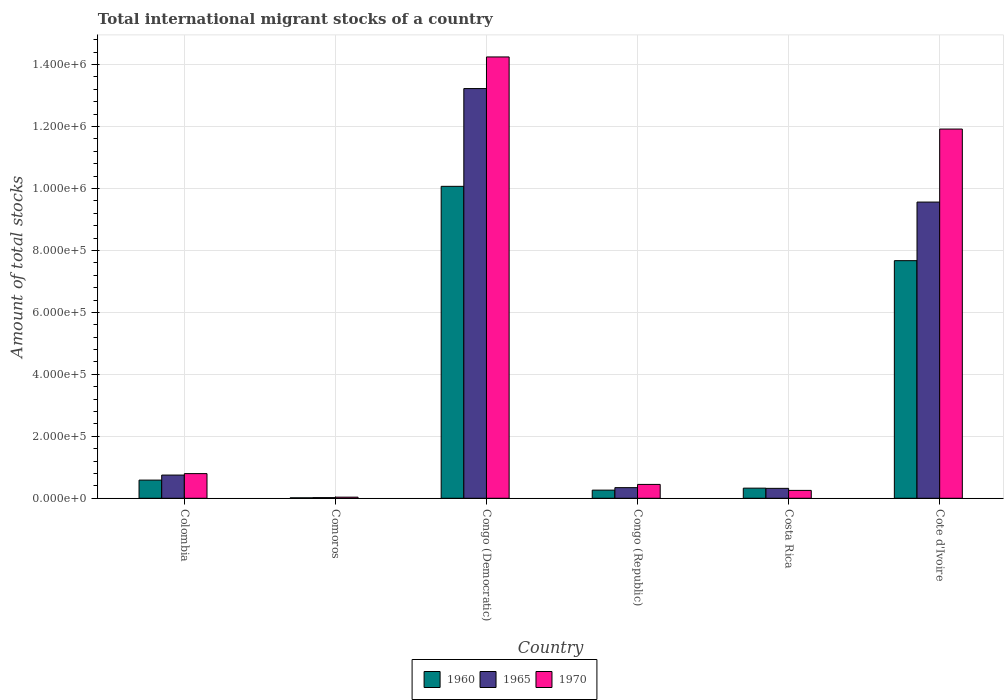How many groups of bars are there?
Your answer should be compact. 6. Are the number of bars on each tick of the X-axis equal?
Provide a short and direct response. Yes. What is the amount of total stocks in in 1965 in Comoros?
Give a very brief answer. 2138. Across all countries, what is the maximum amount of total stocks in in 1965?
Ensure brevity in your answer.  1.32e+06. Across all countries, what is the minimum amount of total stocks in in 1965?
Give a very brief answer. 2138. In which country was the amount of total stocks in in 1970 maximum?
Offer a very short reply. Congo (Democratic). In which country was the amount of total stocks in in 1965 minimum?
Offer a terse response. Comoros. What is the total amount of total stocks in in 1965 in the graph?
Make the answer very short. 2.42e+06. What is the difference between the amount of total stocks in in 1970 in Colombia and that in Congo (Democratic)?
Provide a succinct answer. -1.34e+06. What is the difference between the amount of total stocks in in 1965 in Congo (Democratic) and the amount of total stocks in in 1970 in Costa Rica?
Offer a terse response. 1.30e+06. What is the average amount of total stocks in in 1965 per country?
Your answer should be very brief. 4.04e+05. What is the difference between the amount of total stocks in of/in 1960 and amount of total stocks in of/in 1965 in Comoros?
Give a very brief answer. -631. What is the ratio of the amount of total stocks in in 1960 in Congo (Democratic) to that in Cote d'Ivoire?
Your answer should be compact. 1.31. Is the amount of total stocks in in 1960 in Colombia less than that in Congo (Democratic)?
Offer a terse response. Yes. What is the difference between the highest and the second highest amount of total stocks in in 1970?
Offer a very short reply. -2.33e+05. What is the difference between the highest and the lowest amount of total stocks in in 1960?
Ensure brevity in your answer.  1.01e+06. Is the sum of the amount of total stocks in in 1960 in Congo (Democratic) and Congo (Republic) greater than the maximum amount of total stocks in in 1965 across all countries?
Your response must be concise. No. What does the 1st bar from the left in Comoros represents?
Your answer should be compact. 1960. Is it the case that in every country, the sum of the amount of total stocks in in 1970 and amount of total stocks in in 1965 is greater than the amount of total stocks in in 1960?
Ensure brevity in your answer.  Yes. How many bars are there?
Give a very brief answer. 18. How many countries are there in the graph?
Make the answer very short. 6. What is the difference between two consecutive major ticks on the Y-axis?
Ensure brevity in your answer.  2.00e+05. Are the values on the major ticks of Y-axis written in scientific E-notation?
Give a very brief answer. Yes. Where does the legend appear in the graph?
Your answer should be very brief. Bottom center. What is the title of the graph?
Offer a terse response. Total international migrant stocks of a country. Does "1991" appear as one of the legend labels in the graph?
Your answer should be compact. No. What is the label or title of the Y-axis?
Your response must be concise. Amount of total stocks. What is the Amount of total stocks in 1960 in Colombia?
Give a very brief answer. 5.87e+04. What is the Amount of total stocks of 1965 in Colombia?
Your response must be concise. 7.49e+04. What is the Amount of total stocks of 1970 in Colombia?
Provide a succinct answer. 7.96e+04. What is the Amount of total stocks in 1960 in Comoros?
Offer a terse response. 1507. What is the Amount of total stocks in 1965 in Comoros?
Your response must be concise. 2138. What is the Amount of total stocks in 1970 in Comoros?
Provide a succinct answer. 3614. What is the Amount of total stocks of 1960 in Congo (Democratic)?
Provide a succinct answer. 1.01e+06. What is the Amount of total stocks in 1965 in Congo (Democratic)?
Keep it short and to the point. 1.32e+06. What is the Amount of total stocks in 1970 in Congo (Democratic)?
Offer a terse response. 1.42e+06. What is the Amount of total stocks of 1960 in Congo (Republic)?
Make the answer very short. 2.63e+04. What is the Amount of total stocks of 1965 in Congo (Republic)?
Your response must be concise. 3.43e+04. What is the Amount of total stocks of 1970 in Congo (Republic)?
Your answer should be compact. 4.48e+04. What is the Amount of total stocks in 1960 in Costa Rica?
Give a very brief answer. 3.27e+04. What is the Amount of total stocks of 1965 in Costa Rica?
Your response must be concise. 3.21e+04. What is the Amount of total stocks in 1970 in Costa Rica?
Your response must be concise. 2.54e+04. What is the Amount of total stocks of 1960 in Cote d'Ivoire?
Offer a terse response. 7.67e+05. What is the Amount of total stocks in 1965 in Cote d'Ivoire?
Ensure brevity in your answer.  9.56e+05. What is the Amount of total stocks in 1970 in Cote d'Ivoire?
Keep it short and to the point. 1.19e+06. Across all countries, what is the maximum Amount of total stocks of 1960?
Make the answer very short. 1.01e+06. Across all countries, what is the maximum Amount of total stocks in 1965?
Your answer should be compact. 1.32e+06. Across all countries, what is the maximum Amount of total stocks in 1970?
Your response must be concise. 1.42e+06. Across all countries, what is the minimum Amount of total stocks of 1960?
Your response must be concise. 1507. Across all countries, what is the minimum Amount of total stocks in 1965?
Give a very brief answer. 2138. Across all countries, what is the minimum Amount of total stocks of 1970?
Your answer should be very brief. 3614. What is the total Amount of total stocks in 1960 in the graph?
Provide a succinct answer. 1.89e+06. What is the total Amount of total stocks in 1965 in the graph?
Give a very brief answer. 2.42e+06. What is the total Amount of total stocks of 1970 in the graph?
Your answer should be compact. 2.77e+06. What is the difference between the Amount of total stocks of 1960 in Colombia and that in Comoros?
Provide a short and direct response. 5.72e+04. What is the difference between the Amount of total stocks of 1965 in Colombia and that in Comoros?
Provide a short and direct response. 7.28e+04. What is the difference between the Amount of total stocks of 1970 in Colombia and that in Comoros?
Offer a terse response. 7.60e+04. What is the difference between the Amount of total stocks in 1960 in Colombia and that in Congo (Democratic)?
Offer a terse response. -9.48e+05. What is the difference between the Amount of total stocks of 1965 in Colombia and that in Congo (Democratic)?
Give a very brief answer. -1.25e+06. What is the difference between the Amount of total stocks of 1970 in Colombia and that in Congo (Democratic)?
Provide a succinct answer. -1.34e+06. What is the difference between the Amount of total stocks of 1960 in Colombia and that in Congo (Republic)?
Your answer should be compact. 3.24e+04. What is the difference between the Amount of total stocks in 1965 in Colombia and that in Congo (Republic)?
Give a very brief answer. 4.06e+04. What is the difference between the Amount of total stocks of 1970 in Colombia and that in Congo (Republic)?
Offer a very short reply. 3.48e+04. What is the difference between the Amount of total stocks in 1960 in Colombia and that in Costa Rica?
Give a very brief answer. 2.60e+04. What is the difference between the Amount of total stocks of 1965 in Colombia and that in Costa Rica?
Your answer should be very brief. 4.28e+04. What is the difference between the Amount of total stocks of 1970 in Colombia and that in Costa Rica?
Offer a terse response. 5.42e+04. What is the difference between the Amount of total stocks of 1960 in Colombia and that in Cote d'Ivoire?
Your answer should be very brief. -7.08e+05. What is the difference between the Amount of total stocks in 1965 in Colombia and that in Cote d'Ivoire?
Offer a very short reply. -8.81e+05. What is the difference between the Amount of total stocks of 1970 in Colombia and that in Cote d'Ivoire?
Your answer should be very brief. -1.11e+06. What is the difference between the Amount of total stocks in 1960 in Comoros and that in Congo (Democratic)?
Your response must be concise. -1.01e+06. What is the difference between the Amount of total stocks in 1965 in Comoros and that in Congo (Democratic)?
Your response must be concise. -1.32e+06. What is the difference between the Amount of total stocks in 1970 in Comoros and that in Congo (Democratic)?
Ensure brevity in your answer.  -1.42e+06. What is the difference between the Amount of total stocks in 1960 in Comoros and that in Congo (Republic)?
Provide a succinct answer. -2.48e+04. What is the difference between the Amount of total stocks of 1965 in Comoros and that in Congo (Republic)?
Your answer should be compact. -3.22e+04. What is the difference between the Amount of total stocks in 1970 in Comoros and that in Congo (Republic)?
Your answer should be compact. -4.12e+04. What is the difference between the Amount of total stocks of 1960 in Comoros and that in Costa Rica?
Give a very brief answer. -3.12e+04. What is the difference between the Amount of total stocks in 1965 in Comoros and that in Costa Rica?
Your answer should be compact. -2.99e+04. What is the difference between the Amount of total stocks in 1970 in Comoros and that in Costa Rica?
Offer a very short reply. -2.18e+04. What is the difference between the Amount of total stocks of 1960 in Comoros and that in Cote d'Ivoire?
Your response must be concise. -7.66e+05. What is the difference between the Amount of total stocks of 1965 in Comoros and that in Cote d'Ivoire?
Provide a short and direct response. -9.54e+05. What is the difference between the Amount of total stocks of 1970 in Comoros and that in Cote d'Ivoire?
Your response must be concise. -1.19e+06. What is the difference between the Amount of total stocks of 1960 in Congo (Democratic) and that in Congo (Republic)?
Make the answer very short. 9.81e+05. What is the difference between the Amount of total stocks in 1965 in Congo (Democratic) and that in Congo (Republic)?
Your answer should be very brief. 1.29e+06. What is the difference between the Amount of total stocks in 1970 in Congo (Democratic) and that in Congo (Republic)?
Make the answer very short. 1.38e+06. What is the difference between the Amount of total stocks in 1960 in Congo (Democratic) and that in Costa Rica?
Your answer should be compact. 9.74e+05. What is the difference between the Amount of total stocks in 1965 in Congo (Democratic) and that in Costa Rica?
Make the answer very short. 1.29e+06. What is the difference between the Amount of total stocks in 1970 in Congo (Democratic) and that in Costa Rica?
Your response must be concise. 1.40e+06. What is the difference between the Amount of total stocks of 1960 in Congo (Democratic) and that in Cote d'Ivoire?
Keep it short and to the point. 2.40e+05. What is the difference between the Amount of total stocks in 1965 in Congo (Democratic) and that in Cote d'Ivoire?
Offer a terse response. 3.66e+05. What is the difference between the Amount of total stocks in 1970 in Congo (Democratic) and that in Cote d'Ivoire?
Give a very brief answer. 2.33e+05. What is the difference between the Amount of total stocks in 1960 in Congo (Republic) and that in Costa Rica?
Your answer should be compact. -6378. What is the difference between the Amount of total stocks of 1965 in Congo (Republic) and that in Costa Rica?
Make the answer very short. 2251. What is the difference between the Amount of total stocks of 1970 in Congo (Republic) and that in Costa Rica?
Provide a short and direct response. 1.93e+04. What is the difference between the Amount of total stocks in 1960 in Congo (Republic) and that in Cote d'Ivoire?
Provide a succinct answer. -7.41e+05. What is the difference between the Amount of total stocks in 1965 in Congo (Republic) and that in Cote d'Ivoire?
Offer a very short reply. -9.22e+05. What is the difference between the Amount of total stocks in 1970 in Congo (Republic) and that in Cote d'Ivoire?
Ensure brevity in your answer.  -1.15e+06. What is the difference between the Amount of total stocks of 1960 in Costa Rica and that in Cote d'Ivoire?
Ensure brevity in your answer.  -7.34e+05. What is the difference between the Amount of total stocks in 1965 in Costa Rica and that in Cote d'Ivoire?
Your answer should be very brief. -9.24e+05. What is the difference between the Amount of total stocks of 1970 in Costa Rica and that in Cote d'Ivoire?
Keep it short and to the point. -1.17e+06. What is the difference between the Amount of total stocks of 1960 in Colombia and the Amount of total stocks of 1965 in Comoros?
Provide a short and direct response. 5.65e+04. What is the difference between the Amount of total stocks of 1960 in Colombia and the Amount of total stocks of 1970 in Comoros?
Offer a very short reply. 5.51e+04. What is the difference between the Amount of total stocks in 1965 in Colombia and the Amount of total stocks in 1970 in Comoros?
Offer a very short reply. 7.13e+04. What is the difference between the Amount of total stocks in 1960 in Colombia and the Amount of total stocks in 1965 in Congo (Democratic)?
Your answer should be very brief. -1.26e+06. What is the difference between the Amount of total stocks in 1960 in Colombia and the Amount of total stocks in 1970 in Congo (Democratic)?
Your answer should be very brief. -1.37e+06. What is the difference between the Amount of total stocks of 1965 in Colombia and the Amount of total stocks of 1970 in Congo (Democratic)?
Your answer should be compact. -1.35e+06. What is the difference between the Amount of total stocks of 1960 in Colombia and the Amount of total stocks of 1965 in Congo (Republic)?
Your answer should be compact. 2.44e+04. What is the difference between the Amount of total stocks in 1960 in Colombia and the Amount of total stocks in 1970 in Congo (Republic)?
Your answer should be very brief. 1.39e+04. What is the difference between the Amount of total stocks in 1965 in Colombia and the Amount of total stocks in 1970 in Congo (Republic)?
Your answer should be very brief. 3.01e+04. What is the difference between the Amount of total stocks in 1960 in Colombia and the Amount of total stocks in 1965 in Costa Rica?
Give a very brief answer. 2.66e+04. What is the difference between the Amount of total stocks in 1960 in Colombia and the Amount of total stocks in 1970 in Costa Rica?
Your answer should be very brief. 3.32e+04. What is the difference between the Amount of total stocks of 1965 in Colombia and the Amount of total stocks of 1970 in Costa Rica?
Give a very brief answer. 4.95e+04. What is the difference between the Amount of total stocks in 1960 in Colombia and the Amount of total stocks in 1965 in Cote d'Ivoire?
Offer a very short reply. -8.97e+05. What is the difference between the Amount of total stocks in 1960 in Colombia and the Amount of total stocks in 1970 in Cote d'Ivoire?
Your answer should be very brief. -1.13e+06. What is the difference between the Amount of total stocks in 1965 in Colombia and the Amount of total stocks in 1970 in Cote d'Ivoire?
Make the answer very short. -1.12e+06. What is the difference between the Amount of total stocks of 1960 in Comoros and the Amount of total stocks of 1965 in Congo (Democratic)?
Your response must be concise. -1.32e+06. What is the difference between the Amount of total stocks in 1960 in Comoros and the Amount of total stocks in 1970 in Congo (Democratic)?
Your answer should be very brief. -1.42e+06. What is the difference between the Amount of total stocks in 1965 in Comoros and the Amount of total stocks in 1970 in Congo (Democratic)?
Give a very brief answer. -1.42e+06. What is the difference between the Amount of total stocks in 1960 in Comoros and the Amount of total stocks in 1965 in Congo (Republic)?
Make the answer very short. -3.28e+04. What is the difference between the Amount of total stocks in 1960 in Comoros and the Amount of total stocks in 1970 in Congo (Republic)?
Keep it short and to the point. -4.33e+04. What is the difference between the Amount of total stocks of 1965 in Comoros and the Amount of total stocks of 1970 in Congo (Republic)?
Your response must be concise. -4.26e+04. What is the difference between the Amount of total stocks of 1960 in Comoros and the Amount of total stocks of 1965 in Costa Rica?
Your answer should be very brief. -3.06e+04. What is the difference between the Amount of total stocks of 1960 in Comoros and the Amount of total stocks of 1970 in Costa Rica?
Your answer should be very brief. -2.39e+04. What is the difference between the Amount of total stocks in 1965 in Comoros and the Amount of total stocks in 1970 in Costa Rica?
Provide a short and direct response. -2.33e+04. What is the difference between the Amount of total stocks of 1960 in Comoros and the Amount of total stocks of 1965 in Cote d'Ivoire?
Make the answer very short. -9.55e+05. What is the difference between the Amount of total stocks of 1960 in Comoros and the Amount of total stocks of 1970 in Cote d'Ivoire?
Make the answer very short. -1.19e+06. What is the difference between the Amount of total stocks in 1965 in Comoros and the Amount of total stocks in 1970 in Cote d'Ivoire?
Keep it short and to the point. -1.19e+06. What is the difference between the Amount of total stocks of 1960 in Congo (Democratic) and the Amount of total stocks of 1965 in Congo (Republic)?
Your answer should be compact. 9.73e+05. What is the difference between the Amount of total stocks of 1960 in Congo (Democratic) and the Amount of total stocks of 1970 in Congo (Republic)?
Your answer should be compact. 9.62e+05. What is the difference between the Amount of total stocks in 1965 in Congo (Democratic) and the Amount of total stocks in 1970 in Congo (Republic)?
Your answer should be very brief. 1.28e+06. What is the difference between the Amount of total stocks of 1960 in Congo (Democratic) and the Amount of total stocks of 1965 in Costa Rica?
Provide a short and direct response. 9.75e+05. What is the difference between the Amount of total stocks in 1960 in Congo (Democratic) and the Amount of total stocks in 1970 in Costa Rica?
Provide a short and direct response. 9.81e+05. What is the difference between the Amount of total stocks in 1965 in Congo (Democratic) and the Amount of total stocks in 1970 in Costa Rica?
Your response must be concise. 1.30e+06. What is the difference between the Amount of total stocks of 1960 in Congo (Democratic) and the Amount of total stocks of 1965 in Cote d'Ivoire?
Provide a succinct answer. 5.08e+04. What is the difference between the Amount of total stocks of 1960 in Congo (Democratic) and the Amount of total stocks of 1970 in Cote d'Ivoire?
Offer a very short reply. -1.85e+05. What is the difference between the Amount of total stocks of 1965 in Congo (Democratic) and the Amount of total stocks of 1970 in Cote d'Ivoire?
Give a very brief answer. 1.31e+05. What is the difference between the Amount of total stocks in 1960 in Congo (Republic) and the Amount of total stocks in 1965 in Costa Rica?
Keep it short and to the point. -5758. What is the difference between the Amount of total stocks in 1960 in Congo (Republic) and the Amount of total stocks in 1970 in Costa Rica?
Your response must be concise. 883. What is the difference between the Amount of total stocks in 1965 in Congo (Republic) and the Amount of total stocks in 1970 in Costa Rica?
Your answer should be compact. 8892. What is the difference between the Amount of total stocks in 1960 in Congo (Republic) and the Amount of total stocks in 1965 in Cote d'Ivoire?
Offer a terse response. -9.30e+05. What is the difference between the Amount of total stocks in 1960 in Congo (Republic) and the Amount of total stocks in 1970 in Cote d'Ivoire?
Give a very brief answer. -1.17e+06. What is the difference between the Amount of total stocks of 1965 in Congo (Republic) and the Amount of total stocks of 1970 in Cote d'Ivoire?
Offer a very short reply. -1.16e+06. What is the difference between the Amount of total stocks in 1960 in Costa Rica and the Amount of total stocks in 1965 in Cote d'Ivoire?
Ensure brevity in your answer.  -9.23e+05. What is the difference between the Amount of total stocks of 1960 in Costa Rica and the Amount of total stocks of 1970 in Cote d'Ivoire?
Keep it short and to the point. -1.16e+06. What is the difference between the Amount of total stocks of 1965 in Costa Rica and the Amount of total stocks of 1970 in Cote d'Ivoire?
Give a very brief answer. -1.16e+06. What is the average Amount of total stocks in 1960 per country?
Your answer should be very brief. 3.16e+05. What is the average Amount of total stocks of 1965 per country?
Offer a very short reply. 4.04e+05. What is the average Amount of total stocks of 1970 per country?
Provide a succinct answer. 4.62e+05. What is the difference between the Amount of total stocks of 1960 and Amount of total stocks of 1965 in Colombia?
Offer a terse response. -1.62e+04. What is the difference between the Amount of total stocks in 1960 and Amount of total stocks in 1970 in Colombia?
Your response must be concise. -2.09e+04. What is the difference between the Amount of total stocks of 1965 and Amount of total stocks of 1970 in Colombia?
Ensure brevity in your answer.  -4673. What is the difference between the Amount of total stocks in 1960 and Amount of total stocks in 1965 in Comoros?
Your response must be concise. -631. What is the difference between the Amount of total stocks in 1960 and Amount of total stocks in 1970 in Comoros?
Offer a terse response. -2107. What is the difference between the Amount of total stocks of 1965 and Amount of total stocks of 1970 in Comoros?
Provide a short and direct response. -1476. What is the difference between the Amount of total stocks of 1960 and Amount of total stocks of 1965 in Congo (Democratic)?
Your answer should be compact. -3.16e+05. What is the difference between the Amount of total stocks of 1960 and Amount of total stocks of 1970 in Congo (Democratic)?
Ensure brevity in your answer.  -4.18e+05. What is the difference between the Amount of total stocks of 1965 and Amount of total stocks of 1970 in Congo (Democratic)?
Make the answer very short. -1.02e+05. What is the difference between the Amount of total stocks of 1960 and Amount of total stocks of 1965 in Congo (Republic)?
Make the answer very short. -8009. What is the difference between the Amount of total stocks of 1960 and Amount of total stocks of 1970 in Congo (Republic)?
Provide a short and direct response. -1.85e+04. What is the difference between the Amount of total stocks in 1965 and Amount of total stocks in 1970 in Congo (Republic)?
Make the answer very short. -1.04e+04. What is the difference between the Amount of total stocks in 1960 and Amount of total stocks in 1965 in Costa Rica?
Make the answer very short. 620. What is the difference between the Amount of total stocks in 1960 and Amount of total stocks in 1970 in Costa Rica?
Provide a succinct answer. 7261. What is the difference between the Amount of total stocks in 1965 and Amount of total stocks in 1970 in Costa Rica?
Give a very brief answer. 6641. What is the difference between the Amount of total stocks in 1960 and Amount of total stocks in 1965 in Cote d'Ivoire?
Provide a succinct answer. -1.89e+05. What is the difference between the Amount of total stocks in 1960 and Amount of total stocks in 1970 in Cote d'Ivoire?
Give a very brief answer. -4.25e+05. What is the difference between the Amount of total stocks of 1965 and Amount of total stocks of 1970 in Cote d'Ivoire?
Your answer should be very brief. -2.36e+05. What is the ratio of the Amount of total stocks of 1960 in Colombia to that in Comoros?
Make the answer very short. 38.94. What is the ratio of the Amount of total stocks of 1965 in Colombia to that in Comoros?
Your answer should be very brief. 35.04. What is the ratio of the Amount of total stocks in 1970 in Colombia to that in Comoros?
Keep it short and to the point. 22.02. What is the ratio of the Amount of total stocks of 1960 in Colombia to that in Congo (Democratic)?
Give a very brief answer. 0.06. What is the ratio of the Amount of total stocks in 1965 in Colombia to that in Congo (Democratic)?
Offer a terse response. 0.06. What is the ratio of the Amount of total stocks in 1970 in Colombia to that in Congo (Democratic)?
Your response must be concise. 0.06. What is the ratio of the Amount of total stocks of 1960 in Colombia to that in Congo (Republic)?
Make the answer very short. 2.23. What is the ratio of the Amount of total stocks in 1965 in Colombia to that in Congo (Republic)?
Give a very brief answer. 2.18. What is the ratio of the Amount of total stocks in 1970 in Colombia to that in Congo (Republic)?
Your answer should be compact. 1.78. What is the ratio of the Amount of total stocks of 1960 in Colombia to that in Costa Rica?
Your answer should be very brief. 1.79. What is the ratio of the Amount of total stocks in 1965 in Colombia to that in Costa Rica?
Your response must be concise. 2.34. What is the ratio of the Amount of total stocks in 1970 in Colombia to that in Costa Rica?
Offer a very short reply. 3.13. What is the ratio of the Amount of total stocks in 1960 in Colombia to that in Cote d'Ivoire?
Keep it short and to the point. 0.08. What is the ratio of the Amount of total stocks of 1965 in Colombia to that in Cote d'Ivoire?
Your response must be concise. 0.08. What is the ratio of the Amount of total stocks of 1970 in Colombia to that in Cote d'Ivoire?
Make the answer very short. 0.07. What is the ratio of the Amount of total stocks in 1960 in Comoros to that in Congo (Democratic)?
Give a very brief answer. 0. What is the ratio of the Amount of total stocks of 1965 in Comoros to that in Congo (Democratic)?
Provide a short and direct response. 0. What is the ratio of the Amount of total stocks of 1970 in Comoros to that in Congo (Democratic)?
Your answer should be very brief. 0. What is the ratio of the Amount of total stocks in 1960 in Comoros to that in Congo (Republic)?
Offer a very short reply. 0.06. What is the ratio of the Amount of total stocks of 1965 in Comoros to that in Congo (Republic)?
Your answer should be compact. 0.06. What is the ratio of the Amount of total stocks of 1970 in Comoros to that in Congo (Republic)?
Give a very brief answer. 0.08. What is the ratio of the Amount of total stocks in 1960 in Comoros to that in Costa Rica?
Give a very brief answer. 0.05. What is the ratio of the Amount of total stocks of 1965 in Comoros to that in Costa Rica?
Offer a very short reply. 0.07. What is the ratio of the Amount of total stocks of 1970 in Comoros to that in Costa Rica?
Offer a terse response. 0.14. What is the ratio of the Amount of total stocks in 1960 in Comoros to that in Cote d'Ivoire?
Your answer should be very brief. 0. What is the ratio of the Amount of total stocks in 1965 in Comoros to that in Cote d'Ivoire?
Provide a short and direct response. 0. What is the ratio of the Amount of total stocks in 1970 in Comoros to that in Cote d'Ivoire?
Offer a terse response. 0. What is the ratio of the Amount of total stocks of 1960 in Congo (Democratic) to that in Congo (Republic)?
Provide a succinct answer. 38.26. What is the ratio of the Amount of total stocks of 1965 in Congo (Democratic) to that in Congo (Republic)?
Your answer should be very brief. 38.53. What is the ratio of the Amount of total stocks of 1970 in Congo (Democratic) to that in Congo (Republic)?
Your response must be concise. 31.82. What is the ratio of the Amount of total stocks in 1960 in Congo (Democratic) to that in Costa Rica?
Give a very brief answer. 30.8. What is the ratio of the Amount of total stocks of 1965 in Congo (Democratic) to that in Costa Rica?
Offer a terse response. 41.23. What is the ratio of the Amount of total stocks of 1970 in Congo (Democratic) to that in Costa Rica?
Make the answer very short. 56.02. What is the ratio of the Amount of total stocks in 1960 in Congo (Democratic) to that in Cote d'Ivoire?
Your response must be concise. 1.31. What is the ratio of the Amount of total stocks of 1965 in Congo (Democratic) to that in Cote d'Ivoire?
Ensure brevity in your answer.  1.38. What is the ratio of the Amount of total stocks of 1970 in Congo (Democratic) to that in Cote d'Ivoire?
Ensure brevity in your answer.  1.2. What is the ratio of the Amount of total stocks in 1960 in Congo (Republic) to that in Costa Rica?
Provide a short and direct response. 0.8. What is the ratio of the Amount of total stocks of 1965 in Congo (Republic) to that in Costa Rica?
Provide a succinct answer. 1.07. What is the ratio of the Amount of total stocks of 1970 in Congo (Republic) to that in Costa Rica?
Keep it short and to the point. 1.76. What is the ratio of the Amount of total stocks of 1960 in Congo (Republic) to that in Cote d'Ivoire?
Make the answer very short. 0.03. What is the ratio of the Amount of total stocks of 1965 in Congo (Republic) to that in Cote d'Ivoire?
Your answer should be very brief. 0.04. What is the ratio of the Amount of total stocks of 1970 in Congo (Republic) to that in Cote d'Ivoire?
Make the answer very short. 0.04. What is the ratio of the Amount of total stocks of 1960 in Costa Rica to that in Cote d'Ivoire?
Ensure brevity in your answer.  0.04. What is the ratio of the Amount of total stocks in 1965 in Costa Rica to that in Cote d'Ivoire?
Your answer should be very brief. 0.03. What is the ratio of the Amount of total stocks in 1970 in Costa Rica to that in Cote d'Ivoire?
Offer a very short reply. 0.02. What is the difference between the highest and the second highest Amount of total stocks in 1960?
Offer a very short reply. 2.40e+05. What is the difference between the highest and the second highest Amount of total stocks of 1965?
Provide a short and direct response. 3.66e+05. What is the difference between the highest and the second highest Amount of total stocks in 1970?
Ensure brevity in your answer.  2.33e+05. What is the difference between the highest and the lowest Amount of total stocks of 1960?
Keep it short and to the point. 1.01e+06. What is the difference between the highest and the lowest Amount of total stocks of 1965?
Give a very brief answer. 1.32e+06. What is the difference between the highest and the lowest Amount of total stocks in 1970?
Make the answer very short. 1.42e+06. 